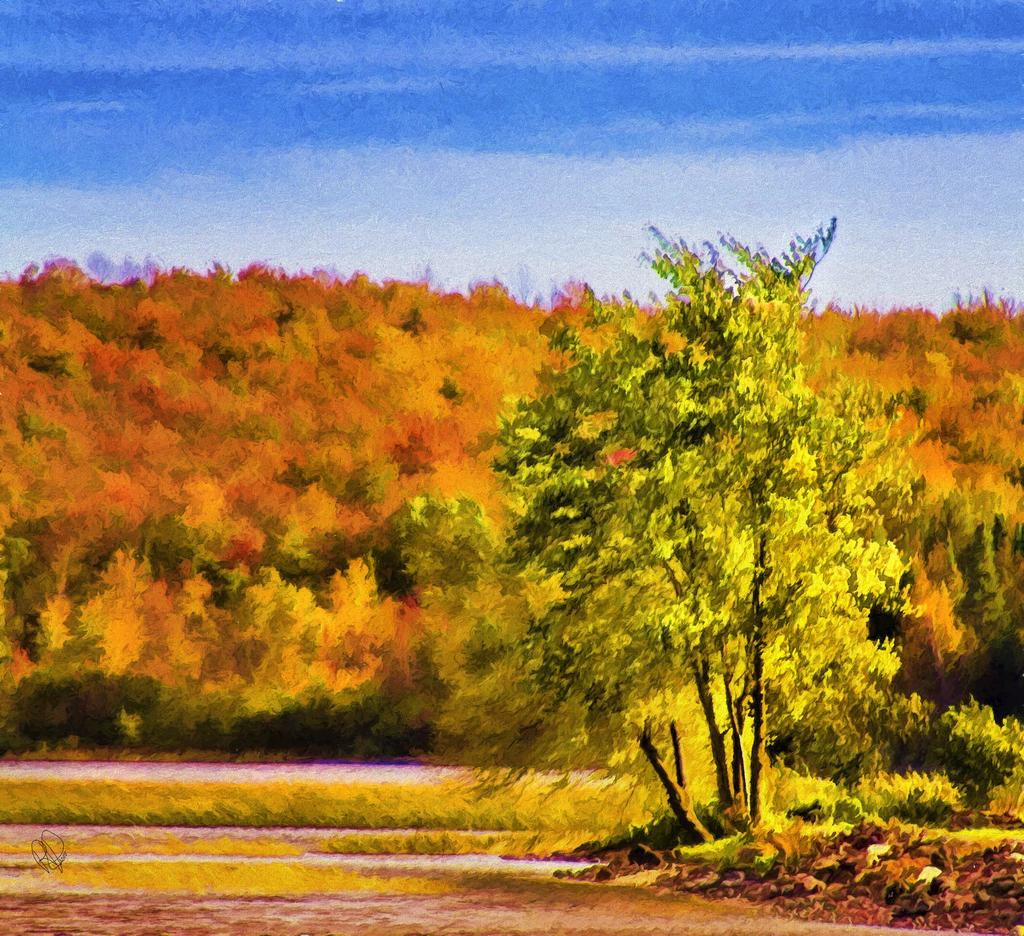What type of vegetation can be seen in the image? There are trees in the image. What part of the natural environment is visible in the image? The sky is visible in the image. What type of jeans is the person wearing in the image? There is no person or jeans present in the image; it only features trees and the sky. 